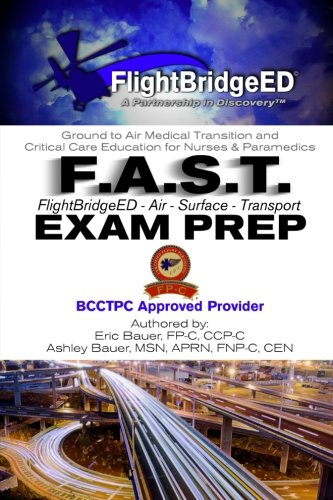Is this a financial book? No, this book focuses on medical exam preparation and does not delve into financial topics or finance-related content. 